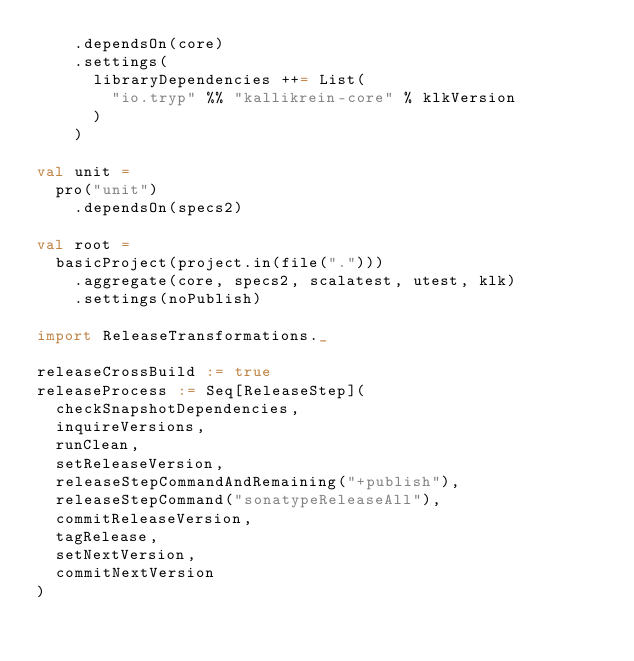<code> <loc_0><loc_0><loc_500><loc_500><_Scala_>    .dependsOn(core)
    .settings(
      libraryDependencies ++= List(
        "io.tryp" %% "kallikrein-core" % klkVersion
      )
    )

val unit =
  pro("unit")
    .dependsOn(specs2)

val root =
  basicProject(project.in(file(".")))
    .aggregate(core, specs2, scalatest, utest, klk)
    .settings(noPublish)

import ReleaseTransformations._

releaseCrossBuild := true
releaseProcess := Seq[ReleaseStep](
  checkSnapshotDependencies,
  inquireVersions,
  runClean,
  setReleaseVersion,
  releaseStepCommandAndRemaining("+publish"),
  releaseStepCommand("sonatypeReleaseAll"),
  commitReleaseVersion,
  tagRelease,
  setNextVersion,
  commitNextVersion
)
</code> 